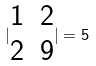Convert formula to latex. <formula><loc_0><loc_0><loc_500><loc_500>| \begin{matrix} 1 & 2 \\ 2 & 9 \\ \end{matrix} | = 5</formula> 